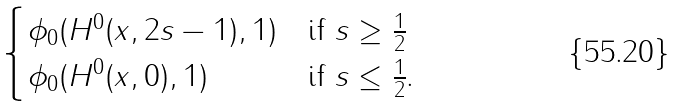Convert formula to latex. <formula><loc_0><loc_0><loc_500><loc_500>\begin{cases} \phi _ { 0 } ( H ^ { 0 } ( x , 2 s - 1 ) , 1 ) & \text {if $s\geq\frac{1}{2}$} \\ \phi _ { 0 } ( H ^ { 0 } ( x , 0 ) , 1 ) & \text {if $s\leq\frac{1}{2}$.} \end{cases}</formula> 